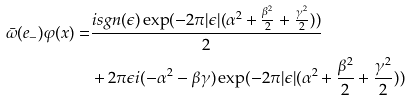Convert formula to latex. <formula><loc_0><loc_0><loc_500><loc_500>\bar { \omega } ( e _ { - } ) \varphi ( x ) = & \frac { i s g n ( \epsilon ) \exp ( - 2 \pi | \epsilon | ( \alpha ^ { 2 } + \frac { \beta ^ { 2 } } { 2 } + \frac { \gamma ^ { 2 } } { 2 } ) ) } { 2 } \\ & + 2 \pi \epsilon i ( - \alpha ^ { 2 } - \beta \gamma ) \exp ( - 2 \pi | \epsilon | ( \alpha ^ { 2 } + \frac { \beta ^ { 2 } } { 2 } + \frac { \gamma ^ { 2 } } { 2 } ) )</formula> 